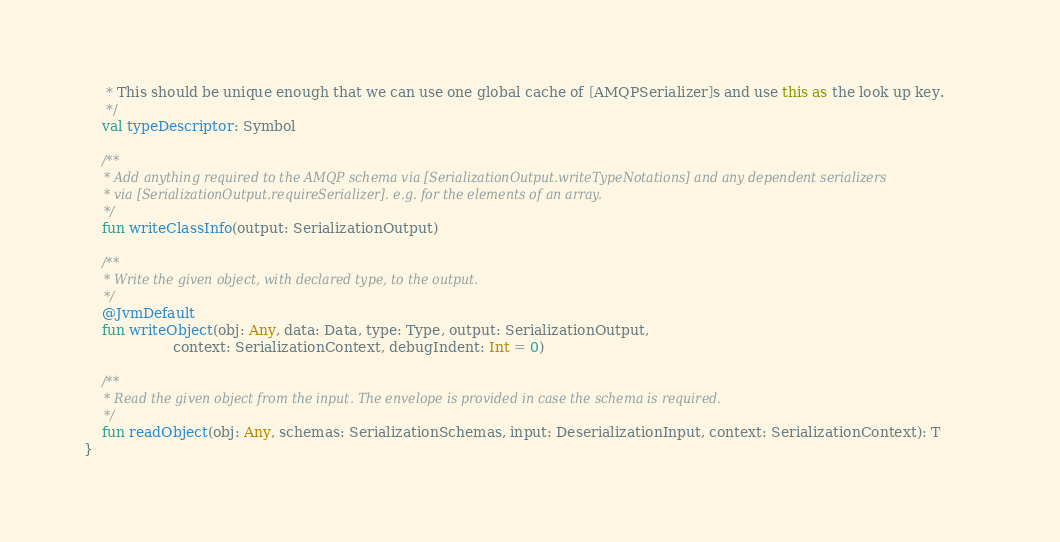<code> <loc_0><loc_0><loc_500><loc_500><_Kotlin_>     * This should be unique enough that we can use one global cache of [AMQPSerializer]s and use this as the look up key.
     */
    val typeDescriptor: Symbol

    /**
     * Add anything required to the AMQP schema via [SerializationOutput.writeTypeNotations] and any dependent serializers
     * via [SerializationOutput.requireSerializer]. e.g. for the elements of an array.
     */
    fun writeClassInfo(output: SerializationOutput)

    /**
     * Write the given object, with declared type, to the output.
     */
    @JvmDefault
    fun writeObject(obj: Any, data: Data, type: Type, output: SerializationOutput,
                    context: SerializationContext, debugIndent: Int = 0)

    /**
     * Read the given object from the input. The envelope is provided in case the schema is required.
     */
    fun readObject(obj: Any, schemas: SerializationSchemas, input: DeserializationInput, context: SerializationContext): T
}
</code> 